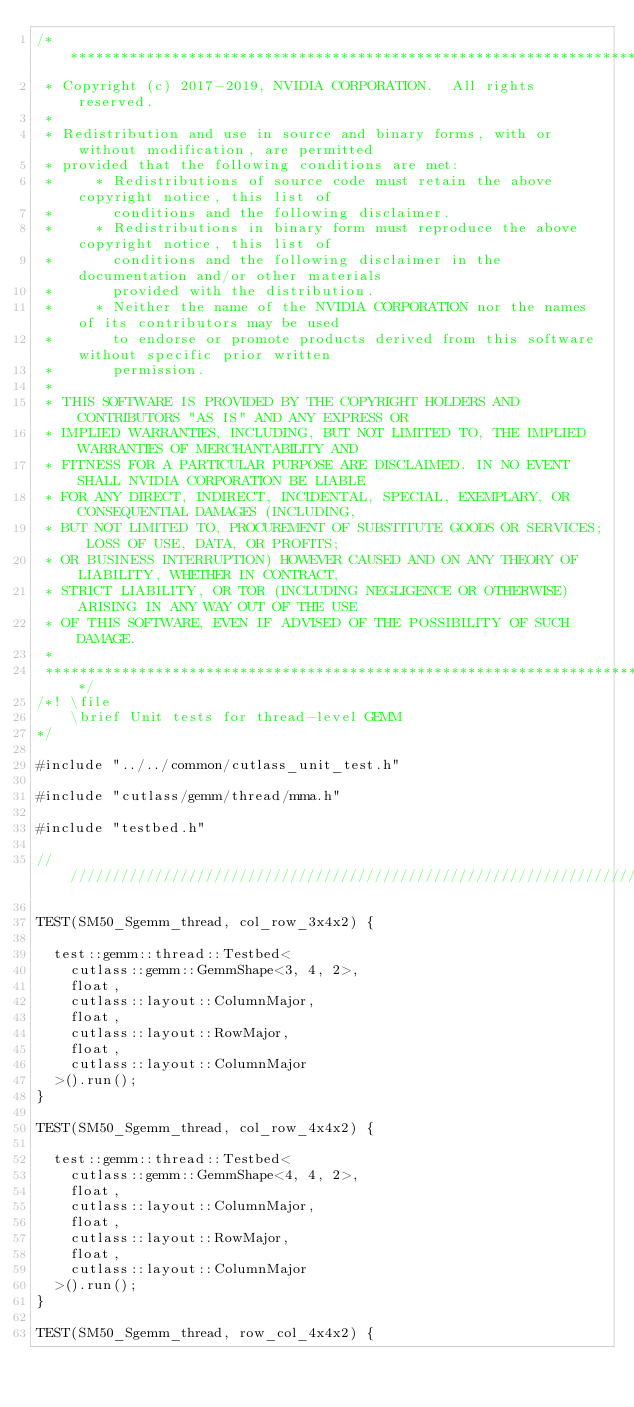<code> <loc_0><loc_0><loc_500><loc_500><_Cuda_>/***************************************************************************************************
 * Copyright (c) 2017-2019, NVIDIA CORPORATION.  All rights reserved.
 *
 * Redistribution and use in source and binary forms, with or without modification, are permitted
 * provided that the following conditions are met:
 *     * Redistributions of source code must retain the above copyright notice, this list of
 *       conditions and the following disclaimer.
 *     * Redistributions in binary form must reproduce the above copyright notice, this list of
 *       conditions and the following disclaimer in the documentation and/or other materials
 *       provided with the distribution.
 *     * Neither the name of the NVIDIA CORPORATION nor the names of its contributors may be used
 *       to endorse or promote products derived from this software without specific prior written
 *       permission.
 *
 * THIS SOFTWARE IS PROVIDED BY THE COPYRIGHT HOLDERS AND CONTRIBUTORS "AS IS" AND ANY EXPRESS OR
 * IMPLIED WARRANTIES, INCLUDING, BUT NOT LIMITED TO, THE IMPLIED WARRANTIES OF MERCHANTABILITY AND
 * FITNESS FOR A PARTICULAR PURPOSE ARE DISCLAIMED. IN NO EVENT SHALL NVIDIA CORPORATION BE LIABLE
 * FOR ANY DIRECT, INDIRECT, INCIDENTAL, SPECIAL, EXEMPLARY, OR CONSEQUENTIAL DAMAGES (INCLUDING,
 * BUT NOT LIMITED TO, PROCUREMENT OF SUBSTITUTE GOODS OR SERVICES; LOSS OF USE, DATA, OR PROFITS;
 * OR BUSINESS INTERRUPTION) HOWEVER CAUSED AND ON ANY THEORY OF LIABILITY, WHETHER IN CONTRACT,
 * STRICT LIABILITY, OR TOR (INCLUDING NEGLIGENCE OR OTHERWISE) ARISING IN ANY WAY OUT OF THE USE
 * OF THIS SOFTWARE, EVEN IF ADVISED OF THE POSSIBILITY OF SUCH DAMAGE.
 *
 **************************************************************************************************/
/*! \file
    \brief Unit tests for thread-level GEMM
*/

#include "../../common/cutlass_unit_test.h"

#include "cutlass/gemm/thread/mma.h"

#include "testbed.h"

/////////////////////////////////////////////////////////////////////////////////////////////////

TEST(SM50_Sgemm_thread, col_row_3x4x2) {

  test::gemm::thread::Testbed<
    cutlass::gemm::GemmShape<3, 4, 2>,
    float,
    cutlass::layout::ColumnMajor,
    float,
    cutlass::layout::RowMajor,
    float,
    cutlass::layout::ColumnMajor
  >().run();
}

TEST(SM50_Sgemm_thread, col_row_4x4x2) {

  test::gemm::thread::Testbed<
    cutlass::gemm::GemmShape<4, 4, 2>,
    float,
    cutlass::layout::ColumnMajor,
    float,
    cutlass::layout::RowMajor,
    float,
    cutlass::layout::ColumnMajor
  >().run();
}

TEST(SM50_Sgemm_thread, row_col_4x4x2) {
</code> 